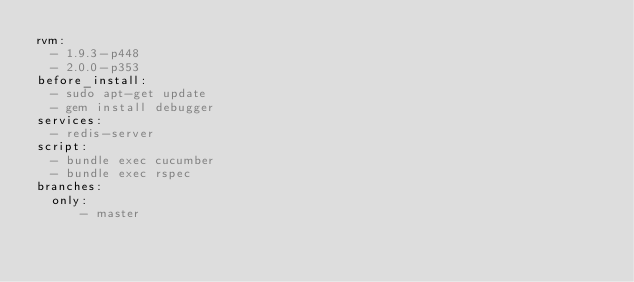Convert code to text. <code><loc_0><loc_0><loc_500><loc_500><_YAML_>rvm:
  - 1.9.3-p448
  - 2.0.0-p353
before_install:
  - sudo apt-get update
  - gem install debugger
services:
  - redis-server
script:
  - bundle exec cucumber
  - bundle exec rspec
branches:
  only:
      - master


</code> 